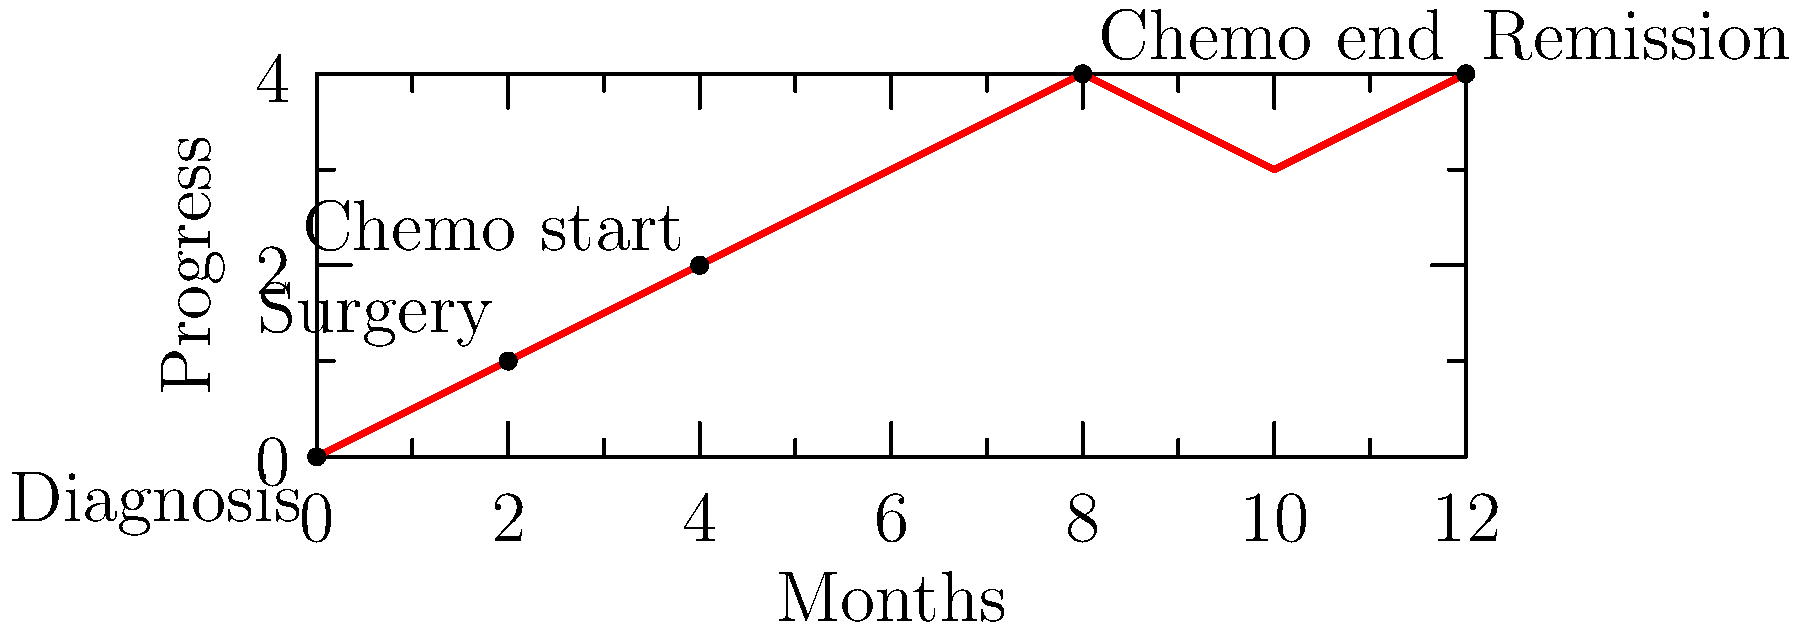Based on the timeline shown, calculate the total duration of active cancer treatment (from diagnosis to the end of chemotherapy) in months. To calculate the total duration of active cancer treatment, we need to follow these steps:

1. Identify the starting point: Diagnosis at 0 months
2. Identify the endpoint: End of chemotherapy
3. Locate the end of chemotherapy on the timeline: 8 months
4. Calculate the difference between the start and end points:
   $8 \text{ months} - 0 \text{ months} = 8 \text{ months}$

The timeline shows the following key events:
- Diagnosis at 0 months
- Surgery at 2 months
- Start of chemotherapy at 4 months
- End of chemotherapy at 8 months
- Remission at 12 months

The active treatment period includes all events from diagnosis to the end of chemotherapy. Therefore, the total duration of active cancer treatment is 8 months.
Answer: 8 months 